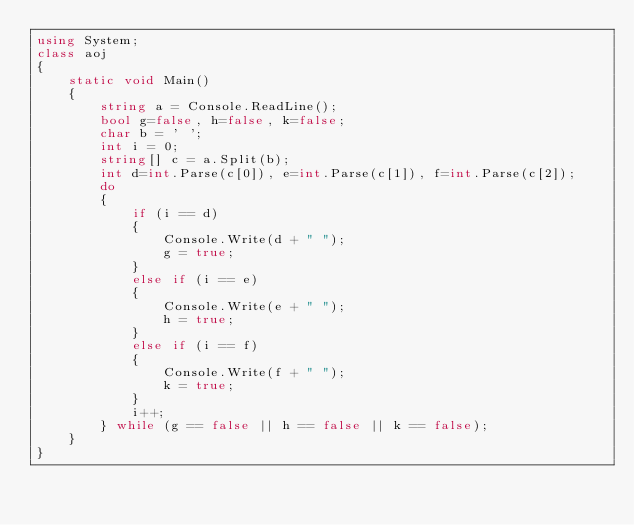Convert code to text. <code><loc_0><loc_0><loc_500><loc_500><_C#_>using System;
class aoj
{
    static void Main()
    {
        string a = Console.ReadLine();
        bool g=false, h=false, k=false;
        char b = ' ';
        int i = 0;
        string[] c = a.Split(b);
        int d=int.Parse(c[0]), e=int.Parse(c[1]), f=int.Parse(c[2]);
        do
        {
            if (i == d)
            {
                Console.Write(d + " ");
                g = true;
            }
            else if (i == e)
            {
                Console.Write(e + " ");
                h = true;
            }
            else if (i == f)
            {
                Console.Write(f + " ");
                k = true;
            }
            i++;
        } while (g == false || h == false || k == false);
    }
}</code> 